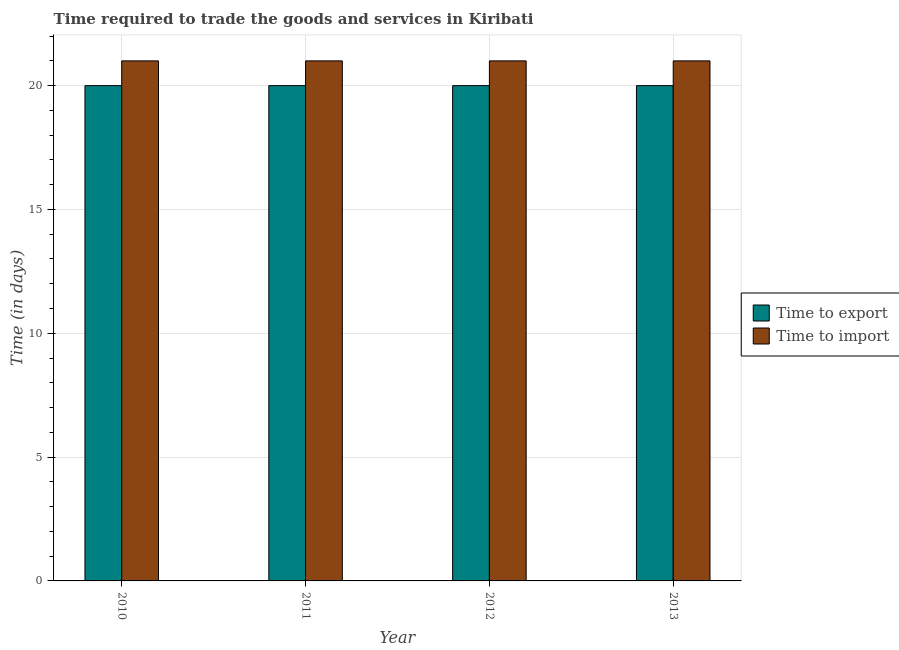How many groups of bars are there?
Provide a short and direct response. 4. Are the number of bars per tick equal to the number of legend labels?
Offer a very short reply. Yes. Are the number of bars on each tick of the X-axis equal?
Ensure brevity in your answer.  Yes. How many bars are there on the 4th tick from the left?
Your response must be concise. 2. How many bars are there on the 4th tick from the right?
Your response must be concise. 2. What is the label of the 3rd group of bars from the left?
Offer a terse response. 2012. What is the time to import in 2012?
Provide a succinct answer. 21. Across all years, what is the maximum time to export?
Provide a succinct answer. 20. Across all years, what is the minimum time to export?
Give a very brief answer. 20. In which year was the time to import maximum?
Provide a short and direct response. 2010. What is the total time to import in the graph?
Make the answer very short. 84. What is the average time to import per year?
Offer a terse response. 21. In how many years, is the time to import greater than 18 days?
Give a very brief answer. 4. What is the difference between the highest and the second highest time to import?
Provide a succinct answer. 0. In how many years, is the time to import greater than the average time to import taken over all years?
Make the answer very short. 0. What does the 1st bar from the left in 2011 represents?
Your answer should be very brief. Time to export. What does the 2nd bar from the right in 2012 represents?
Keep it short and to the point. Time to export. How many bars are there?
Offer a very short reply. 8. Does the graph contain any zero values?
Your answer should be compact. No. Does the graph contain grids?
Provide a succinct answer. Yes. Where does the legend appear in the graph?
Give a very brief answer. Center right. What is the title of the graph?
Give a very brief answer. Time required to trade the goods and services in Kiribati. What is the label or title of the Y-axis?
Offer a terse response. Time (in days). What is the Time (in days) of Time to import in 2010?
Your response must be concise. 21. What is the Time (in days) of Time to import in 2011?
Keep it short and to the point. 21. What is the Time (in days) of Time to export in 2012?
Make the answer very short. 20. What is the Time (in days) in Time to export in 2013?
Your answer should be compact. 20. What is the Time (in days) in Time to import in 2013?
Ensure brevity in your answer.  21. Across all years, what is the maximum Time (in days) in Time to export?
Your answer should be compact. 20. Across all years, what is the maximum Time (in days) in Time to import?
Ensure brevity in your answer.  21. Across all years, what is the minimum Time (in days) of Time to export?
Provide a succinct answer. 20. Across all years, what is the minimum Time (in days) in Time to import?
Provide a short and direct response. 21. What is the total Time (in days) of Time to export in the graph?
Make the answer very short. 80. What is the total Time (in days) in Time to import in the graph?
Offer a very short reply. 84. What is the difference between the Time (in days) in Time to export in 2010 and that in 2011?
Give a very brief answer. 0. What is the difference between the Time (in days) in Time to export in 2010 and that in 2012?
Make the answer very short. 0. What is the difference between the Time (in days) in Time to import in 2010 and that in 2013?
Ensure brevity in your answer.  0. What is the difference between the Time (in days) of Time to import in 2011 and that in 2012?
Your answer should be compact. 0. What is the difference between the Time (in days) in Time to import in 2012 and that in 2013?
Provide a short and direct response. 0. What is the difference between the Time (in days) in Time to export in 2010 and the Time (in days) in Time to import in 2011?
Your answer should be very brief. -1. What is the difference between the Time (in days) in Time to export in 2010 and the Time (in days) in Time to import in 2013?
Your response must be concise. -1. What is the difference between the Time (in days) in Time to export in 2011 and the Time (in days) in Time to import in 2012?
Your answer should be compact. -1. What is the difference between the Time (in days) in Time to export in 2011 and the Time (in days) in Time to import in 2013?
Provide a succinct answer. -1. What is the average Time (in days) of Time to import per year?
Your answer should be very brief. 21. In the year 2010, what is the difference between the Time (in days) in Time to export and Time (in days) in Time to import?
Offer a terse response. -1. In the year 2011, what is the difference between the Time (in days) of Time to export and Time (in days) of Time to import?
Offer a very short reply. -1. In the year 2013, what is the difference between the Time (in days) of Time to export and Time (in days) of Time to import?
Give a very brief answer. -1. What is the ratio of the Time (in days) of Time to export in 2010 to that in 2011?
Ensure brevity in your answer.  1. What is the ratio of the Time (in days) of Time to import in 2010 to that in 2011?
Your response must be concise. 1. What is the ratio of the Time (in days) in Time to export in 2010 to that in 2012?
Keep it short and to the point. 1. What is the ratio of the Time (in days) of Time to import in 2010 to that in 2012?
Provide a short and direct response. 1. What is the ratio of the Time (in days) in Time to export in 2010 to that in 2013?
Keep it short and to the point. 1. What is the ratio of the Time (in days) in Time to export in 2011 to that in 2012?
Give a very brief answer. 1. What is the ratio of the Time (in days) in Time to import in 2011 to that in 2013?
Give a very brief answer. 1. What is the ratio of the Time (in days) in Time to import in 2012 to that in 2013?
Your response must be concise. 1. What is the difference between the highest and the second highest Time (in days) in Time to import?
Give a very brief answer. 0. What is the difference between the highest and the lowest Time (in days) of Time to import?
Make the answer very short. 0. 